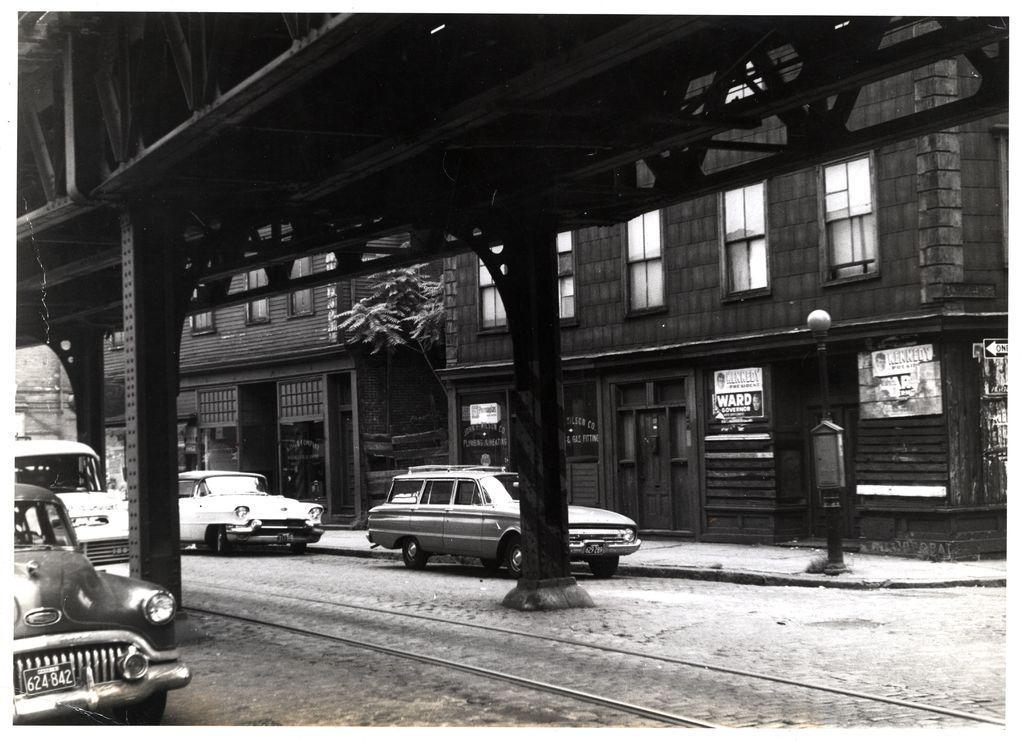How would you summarize this image in a sentence or two? In this image I can see vehicles on the road. Here I can see buildings, trees and other objects on the ground. This picture is black and white in color. 